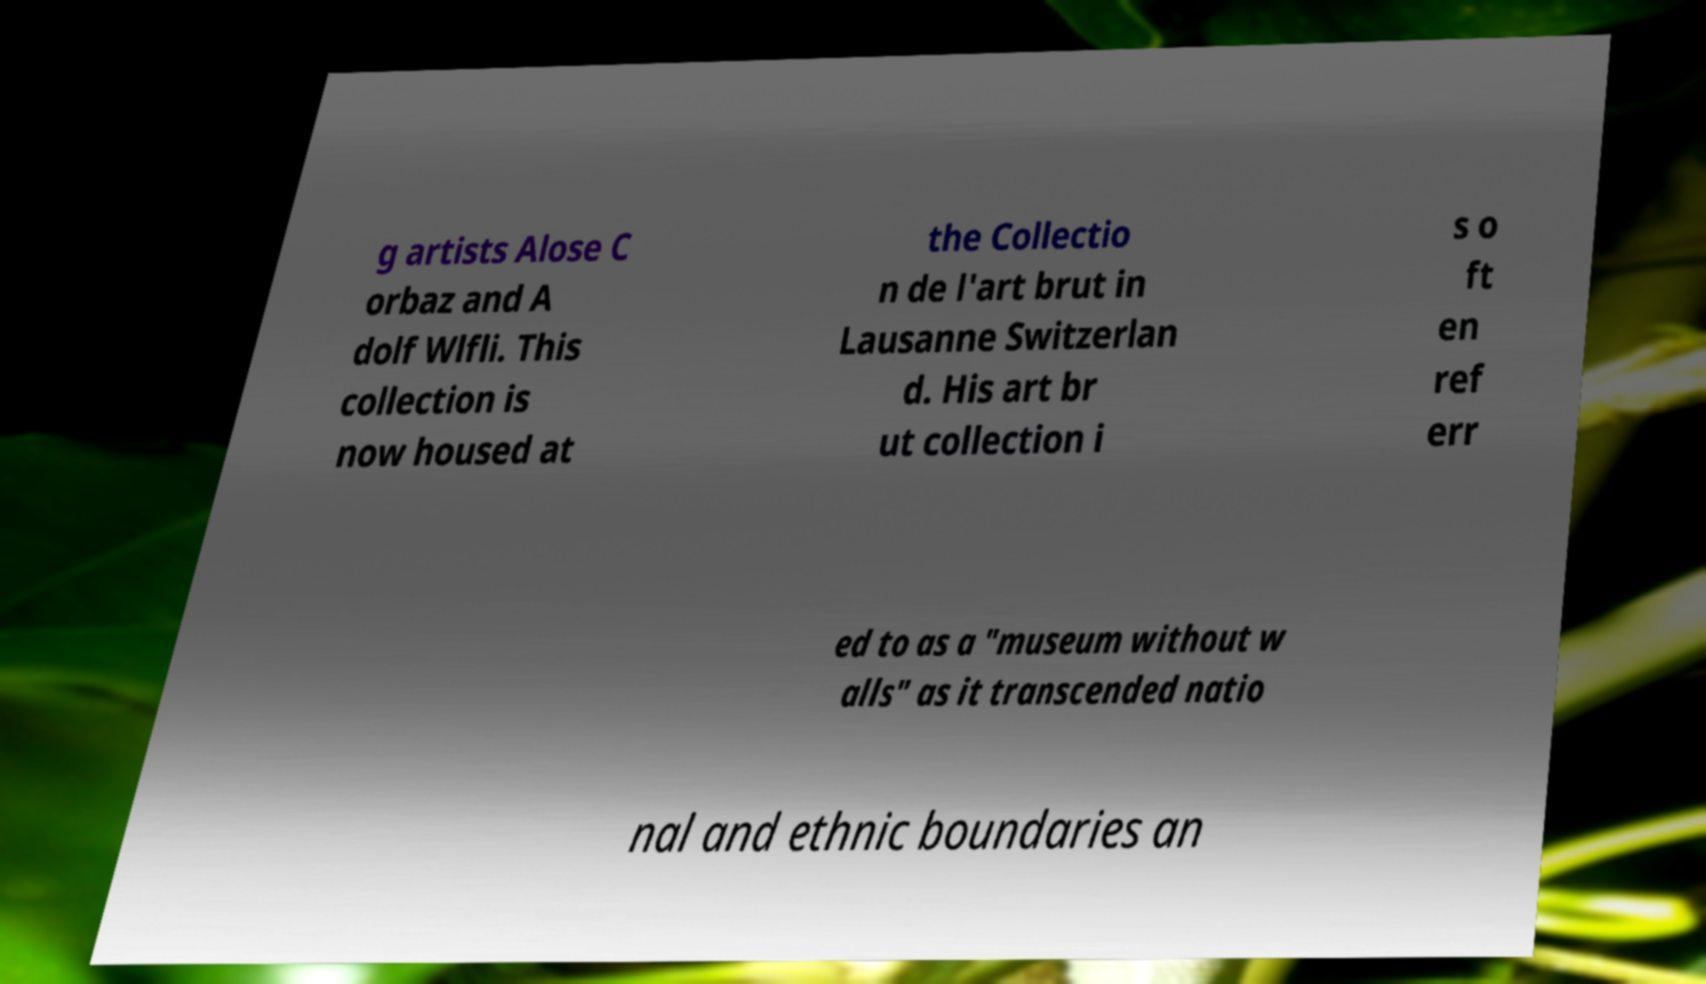Please read and relay the text visible in this image. What does it say? g artists Alose C orbaz and A dolf Wlfli. This collection is now housed at the Collectio n de l'art brut in Lausanne Switzerlan d. His art br ut collection i s o ft en ref err ed to as a "museum without w alls" as it transcended natio nal and ethnic boundaries an 